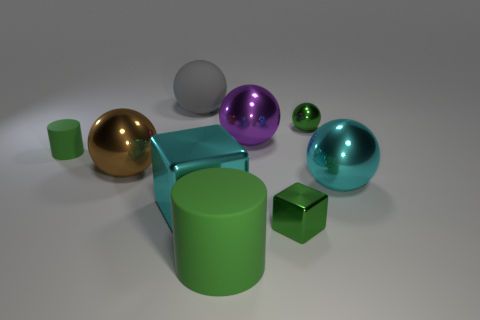Is there a big red cylinder made of the same material as the large green thing?
Offer a terse response. No. The metallic thing that is the same color as the tiny shiny ball is what size?
Your answer should be compact. Small. Are there fewer purple spheres than big blue rubber blocks?
Offer a very short reply. No. Is the color of the matte cylinder in front of the small green rubber cylinder the same as the tiny metal cube?
Keep it short and to the point. Yes. What material is the tiny thing that is behind the green cylinder that is behind the cube that is on the right side of the big purple metallic sphere?
Ensure brevity in your answer.  Metal. Are there any tiny spheres that have the same color as the large rubber ball?
Ensure brevity in your answer.  No. Is the number of green shiny objects that are behind the brown metallic ball less than the number of brown rubber spheres?
Keep it short and to the point. No. Is the size of the rubber cylinder in front of the brown shiny object the same as the cyan metallic cube?
Provide a succinct answer. Yes. How many tiny green things are both behind the big block and right of the large green cylinder?
Make the answer very short. 1. There is a green cylinder that is in front of the big shiny object that is to the right of the tiny green metal sphere; what is its size?
Offer a terse response. Large. 